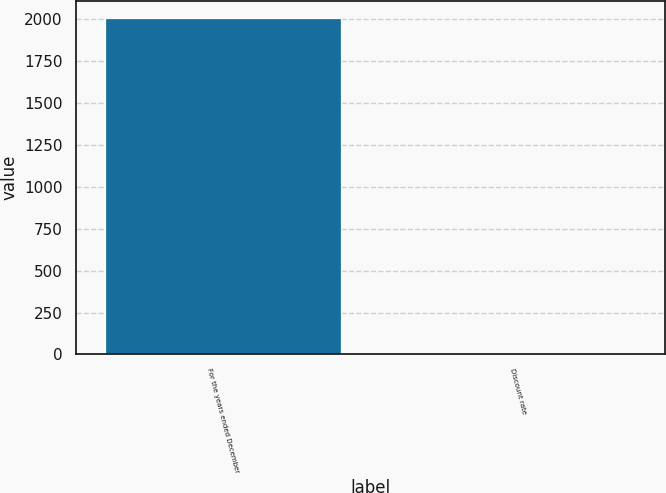<chart> <loc_0><loc_0><loc_500><loc_500><bar_chart><fcel>For the years ended December<fcel>Discount rate<nl><fcel>2009<fcel>6.4<nl></chart> 